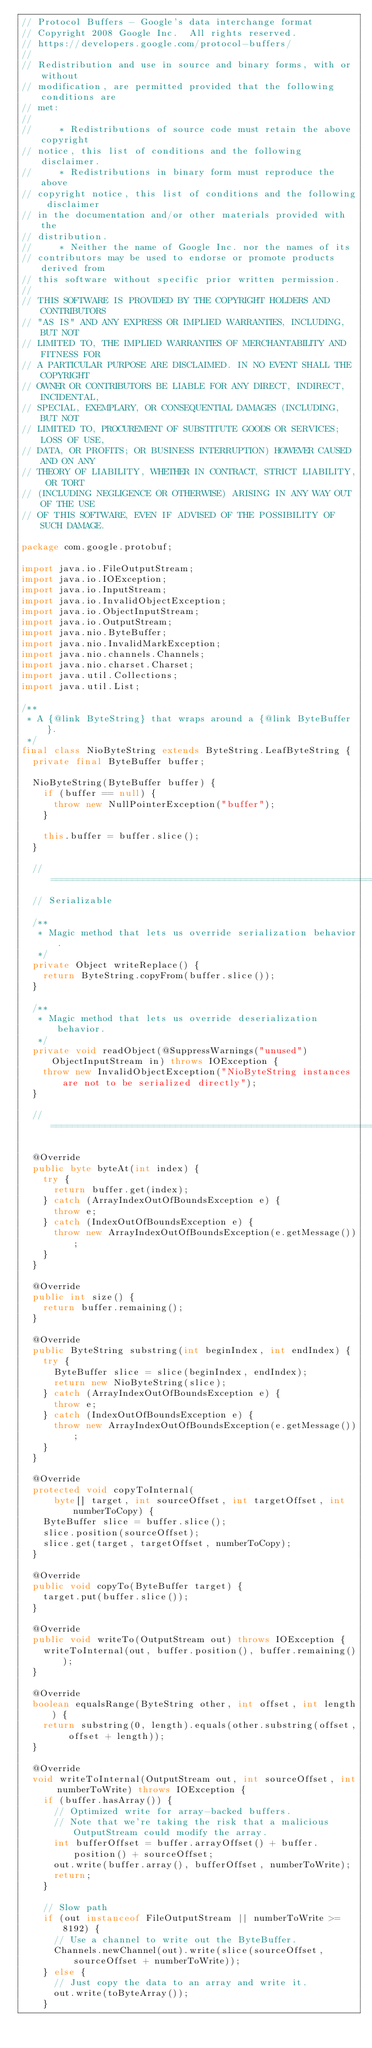Convert code to text. <code><loc_0><loc_0><loc_500><loc_500><_Java_>// Protocol Buffers - Google's data interchange format
// Copyright 2008 Google Inc.  All rights reserved.
// https://developers.google.com/protocol-buffers/
//
// Redistribution and use in source and binary forms, with or without
// modification, are permitted provided that the following conditions are
// met:
//
//     * Redistributions of source code must retain the above copyright
// notice, this list of conditions and the following disclaimer.
//     * Redistributions in binary form must reproduce the above
// copyright notice, this list of conditions and the following disclaimer
// in the documentation and/or other materials provided with the
// distribution.
//     * Neither the name of Google Inc. nor the names of its
// contributors may be used to endorse or promote products derived from
// this software without specific prior written permission.
//
// THIS SOFTWARE IS PROVIDED BY THE COPYRIGHT HOLDERS AND CONTRIBUTORS
// "AS IS" AND ANY EXPRESS OR IMPLIED WARRANTIES, INCLUDING, BUT NOT
// LIMITED TO, THE IMPLIED WARRANTIES OF MERCHANTABILITY AND FITNESS FOR
// A PARTICULAR PURPOSE ARE DISCLAIMED. IN NO EVENT SHALL THE COPYRIGHT
// OWNER OR CONTRIBUTORS BE LIABLE FOR ANY DIRECT, INDIRECT, INCIDENTAL,
// SPECIAL, EXEMPLARY, OR CONSEQUENTIAL DAMAGES (INCLUDING, BUT NOT
// LIMITED TO, PROCUREMENT OF SUBSTITUTE GOODS OR SERVICES; LOSS OF USE,
// DATA, OR PROFITS; OR BUSINESS INTERRUPTION) HOWEVER CAUSED AND ON ANY
// THEORY OF LIABILITY, WHETHER IN CONTRACT, STRICT LIABILITY, OR TORT
// (INCLUDING NEGLIGENCE OR OTHERWISE) ARISING IN ANY WAY OUT OF THE USE
// OF THIS SOFTWARE, EVEN IF ADVISED OF THE POSSIBILITY OF SUCH DAMAGE.

package com.google.protobuf;

import java.io.FileOutputStream;
import java.io.IOException;
import java.io.InputStream;
import java.io.InvalidObjectException;
import java.io.ObjectInputStream;
import java.io.OutputStream;
import java.nio.ByteBuffer;
import java.nio.InvalidMarkException;
import java.nio.channels.Channels;
import java.nio.charset.Charset;
import java.util.Collections;
import java.util.List;

/**
 * A {@link ByteString} that wraps around a {@link ByteBuffer}.
 */
final class NioByteString extends ByteString.LeafByteString {
  private final ByteBuffer buffer;

  NioByteString(ByteBuffer buffer) {
    if (buffer == null) {
      throw new NullPointerException("buffer");
    }

    this.buffer = buffer.slice();
  }

  // =================================================================
  // Serializable

  /**
   * Magic method that lets us override serialization behavior.
   */
  private Object writeReplace() {
    return ByteString.copyFrom(buffer.slice());
  }

  /**
   * Magic method that lets us override deserialization behavior.
   */
  private void readObject(@SuppressWarnings("unused") ObjectInputStream in) throws IOException {
    throw new InvalidObjectException("NioByteString instances are not to be serialized directly");
  }

  // =================================================================

  @Override
  public byte byteAt(int index) {
    try {
      return buffer.get(index);
    } catch (ArrayIndexOutOfBoundsException e) {
      throw e;
    } catch (IndexOutOfBoundsException e) {
      throw new ArrayIndexOutOfBoundsException(e.getMessage());
    }
  }

  @Override
  public int size() {
    return buffer.remaining();
  }

  @Override
  public ByteString substring(int beginIndex, int endIndex) {
    try {
      ByteBuffer slice = slice(beginIndex, endIndex);
      return new NioByteString(slice);
    } catch (ArrayIndexOutOfBoundsException e) {
      throw e;
    } catch (IndexOutOfBoundsException e) {
      throw new ArrayIndexOutOfBoundsException(e.getMessage());
    }
  }

  @Override
  protected void copyToInternal(
      byte[] target, int sourceOffset, int targetOffset, int numberToCopy) {
    ByteBuffer slice = buffer.slice();
    slice.position(sourceOffset);
    slice.get(target, targetOffset, numberToCopy);
  }

  @Override
  public void copyTo(ByteBuffer target) {
    target.put(buffer.slice());
  }

  @Override
  public void writeTo(OutputStream out) throws IOException {
    writeToInternal(out, buffer.position(), buffer.remaining());
  }

  @Override
  boolean equalsRange(ByteString other, int offset, int length) {
    return substring(0, length).equals(other.substring(offset, offset + length));
  }

  @Override
  void writeToInternal(OutputStream out, int sourceOffset, int numberToWrite) throws IOException {
    if (buffer.hasArray()) {
      // Optimized write for array-backed buffers.
      // Note that we're taking the risk that a malicious OutputStream could modify the array.
      int bufferOffset = buffer.arrayOffset() + buffer.position() + sourceOffset;
      out.write(buffer.array(), bufferOffset, numberToWrite);
      return;
    }

    // Slow path
    if (out instanceof FileOutputStream || numberToWrite >= 8192) {
      // Use a channel to write out the ByteBuffer.
      Channels.newChannel(out).write(slice(sourceOffset, sourceOffset + numberToWrite));
    } else {
      // Just copy the data to an array and write it.
      out.write(toByteArray());
    }</code> 